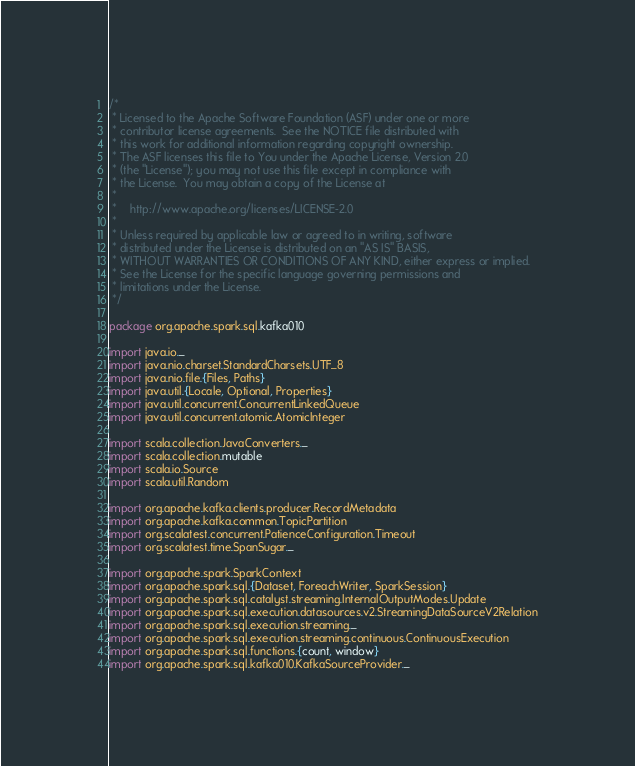<code> <loc_0><loc_0><loc_500><loc_500><_Scala_>/*
 * Licensed to the Apache Software Foundation (ASF) under one or more
 * contributor license agreements.  See the NOTICE file distributed with
 * this work for additional information regarding copyright ownership.
 * The ASF licenses this file to You under the Apache License, Version 2.0
 * (the "License"); you may not use this file except in compliance with
 * the License.  You may obtain a copy of the License at
 *
 *    http://www.apache.org/licenses/LICENSE-2.0
 *
 * Unless required by applicable law or agreed to in writing, software
 * distributed under the License is distributed on an "AS IS" BASIS,
 * WITHOUT WARRANTIES OR CONDITIONS OF ANY KIND, either express or implied.
 * See the License for the specific language governing permissions and
 * limitations under the License.
 */

package org.apache.spark.sql.kafka010

import java.io._
import java.nio.charset.StandardCharsets.UTF_8
import java.nio.file.{Files, Paths}
import java.util.{Locale, Optional, Properties}
import java.util.concurrent.ConcurrentLinkedQueue
import java.util.concurrent.atomic.AtomicInteger

import scala.collection.JavaConverters._
import scala.collection.mutable
import scala.io.Source
import scala.util.Random

import org.apache.kafka.clients.producer.RecordMetadata
import org.apache.kafka.common.TopicPartition
import org.scalatest.concurrent.PatienceConfiguration.Timeout
import org.scalatest.time.SpanSugar._

import org.apache.spark.SparkContext
import org.apache.spark.sql.{Dataset, ForeachWriter, SparkSession}
import org.apache.spark.sql.catalyst.streaming.InternalOutputModes.Update
import org.apache.spark.sql.execution.datasources.v2.StreamingDataSourceV2Relation
import org.apache.spark.sql.execution.streaming._
import org.apache.spark.sql.execution.streaming.continuous.ContinuousExecution
import org.apache.spark.sql.functions.{count, window}
import org.apache.spark.sql.kafka010.KafkaSourceProvider._</code> 